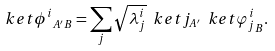<formula> <loc_0><loc_0><loc_500><loc_500>\ k e t { \phi ^ { i } } _ { A ^ { \prime } B } = \sum _ { j } \sqrt { \lambda _ { j } ^ { i } } \ k e t { j } _ { A ^ { \prime } } \ k e t { \varphi _ { j } ^ { i } } _ { B } .</formula> 